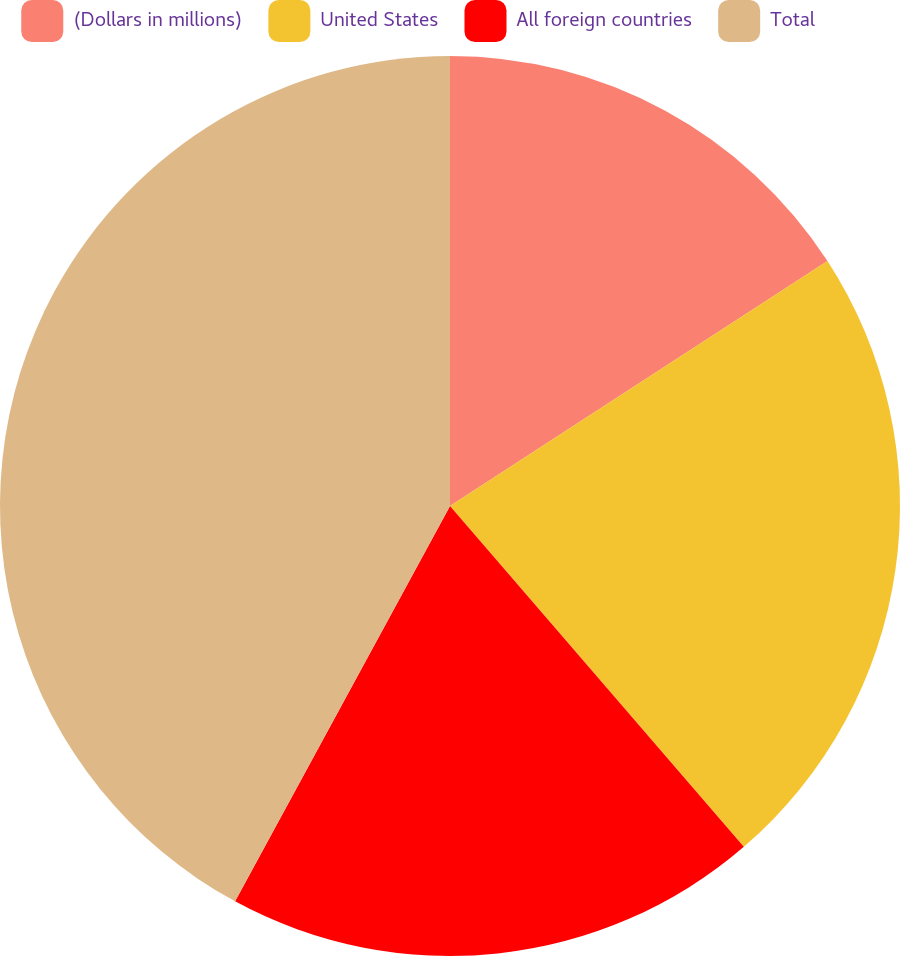<chart> <loc_0><loc_0><loc_500><loc_500><pie_chart><fcel>(Dollars in millions)<fcel>United States<fcel>All foreign countries<fcel>Total<nl><fcel>15.84%<fcel>22.84%<fcel>19.25%<fcel>42.08%<nl></chart> 